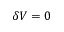Convert formula to latex. <formula><loc_0><loc_0><loc_500><loc_500>\delta V = 0</formula> 